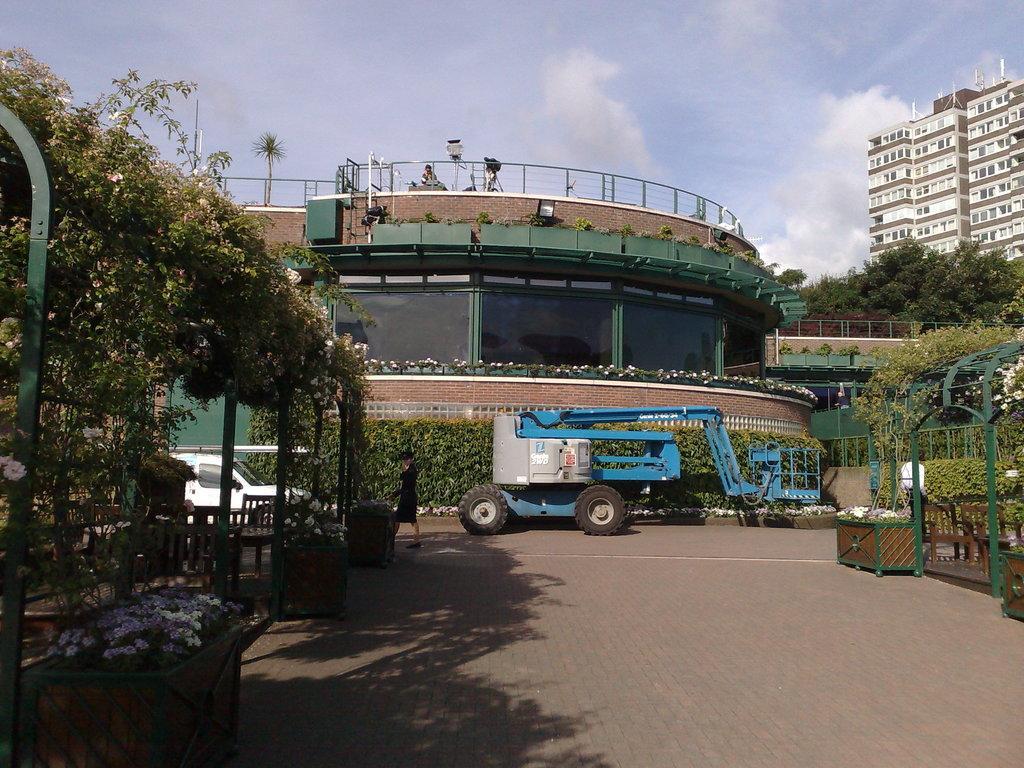Could you give a brief overview of what you see in this image? In this image there is a lady walking on the pavement, behind the lady there are two trucks, in the background of the image there are trees and buildings. 